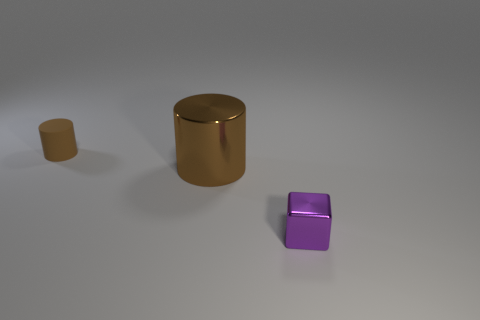What number of big things are behind the purple shiny object?
Keep it short and to the point. 1. Does the brown metallic thing have the same shape as the purple thing?
Your answer should be compact. No. How many tiny objects are both on the left side of the purple shiny object and in front of the small brown matte cylinder?
Ensure brevity in your answer.  0. What number of objects are either large objects or objects on the right side of the large object?
Your response must be concise. 2. Are there more large yellow shiny objects than big brown shiny things?
Keep it short and to the point. No. What shape is the metal thing to the left of the purple metallic cube?
Provide a short and direct response. Cylinder. How many other metallic things have the same shape as the brown metallic thing?
Your answer should be compact. 0. There is a brown object in front of the brown cylinder that is behind the big metallic cylinder; what is its size?
Your response must be concise. Large. How many brown objects are either tiny objects or large metallic cylinders?
Keep it short and to the point. 2. Is the number of small purple blocks that are on the right side of the block less than the number of small blocks behind the rubber cylinder?
Provide a short and direct response. No. 